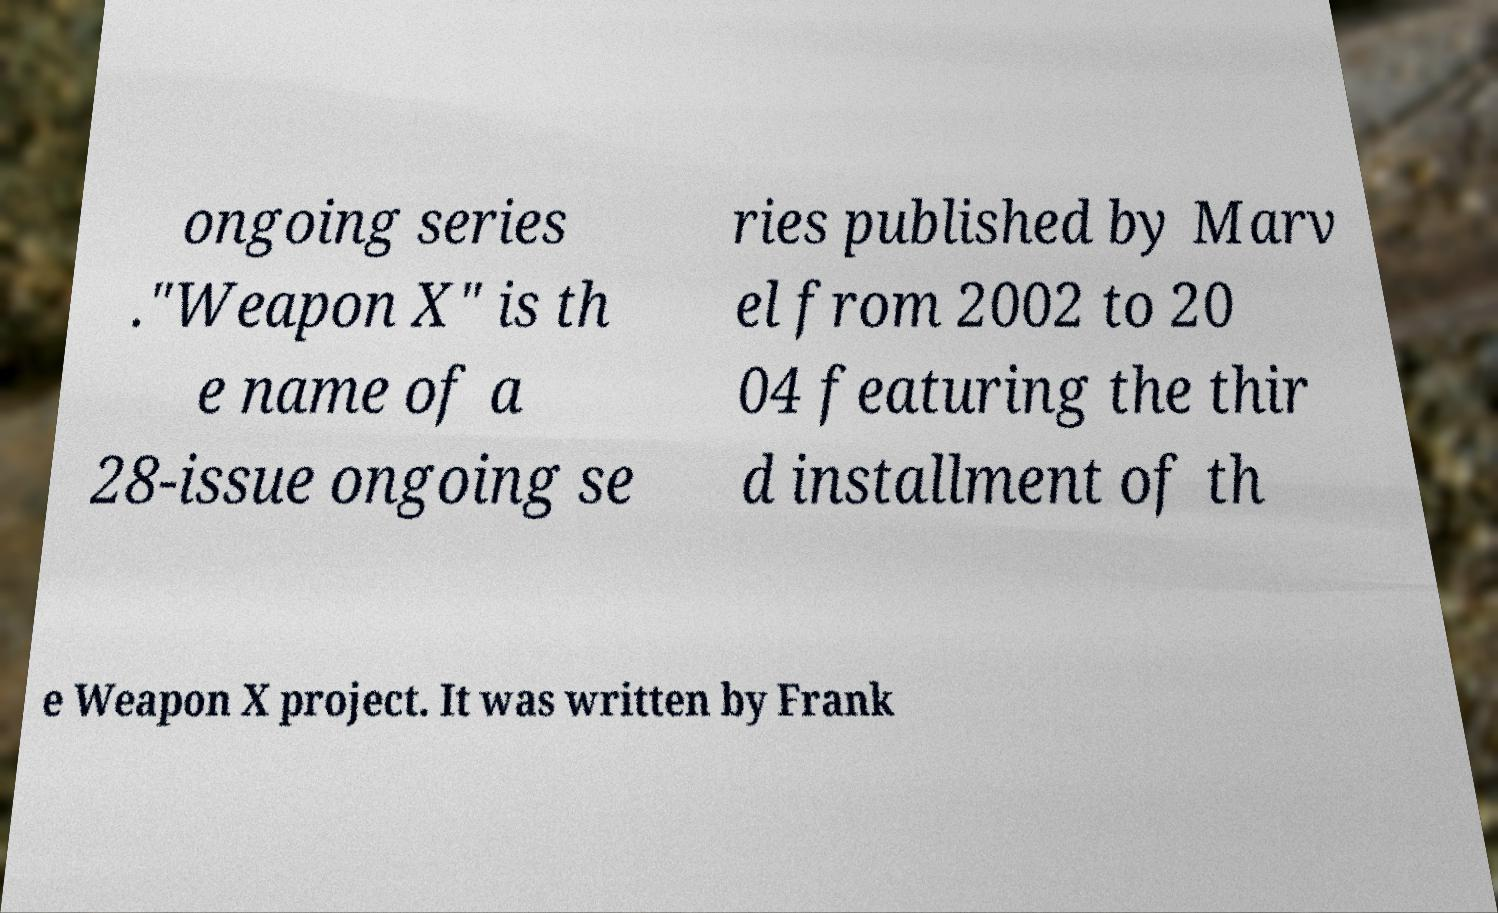I need the written content from this picture converted into text. Can you do that? ongoing series ."Weapon X" is th e name of a 28-issue ongoing se ries published by Marv el from 2002 to 20 04 featuring the thir d installment of th e Weapon X project. It was written by Frank 